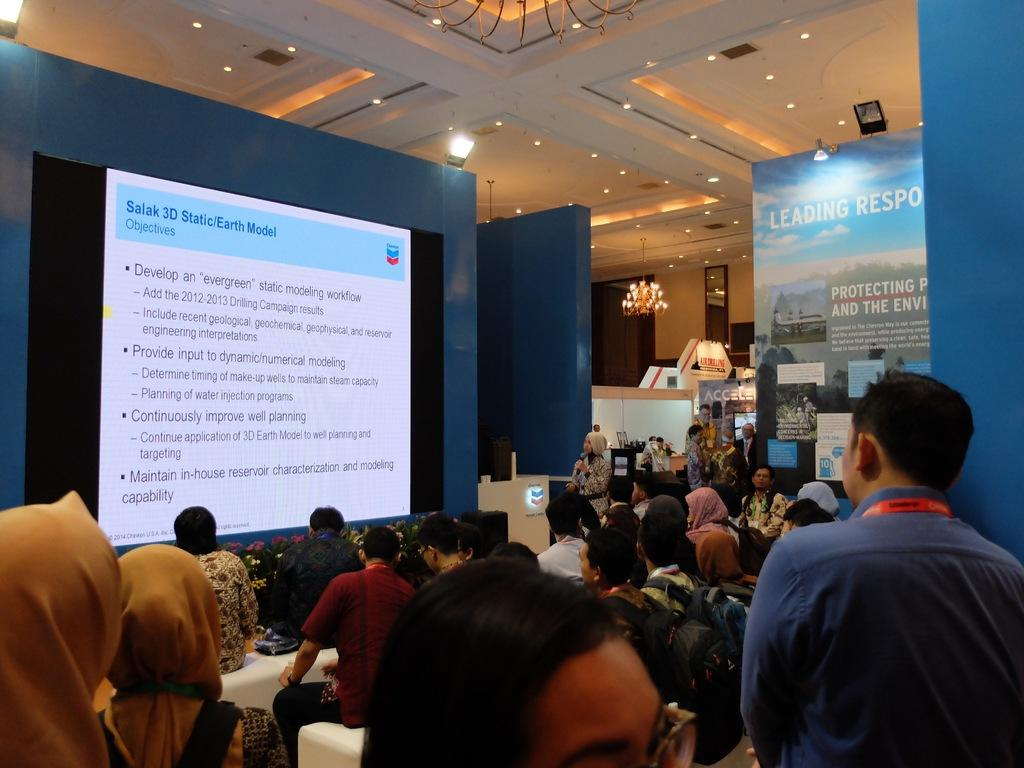Who or what can be seen in the image? There are people in the image. What is hanging or displayed in the image? There is a banner in the image. What is used for displaying information or visuals in the image? There is a screen in the image. What objects are present in the image? There are objects in the image. What can be seen in the background of the image? There is a wall, a chandelier, lights, and a mirror in the background of the image. What type of river is flowing through the image? There is no river present in the image. What fictional character can be seen interacting with the people in the image? There is no fictional character present in the image. 